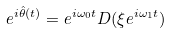Convert formula to latex. <formula><loc_0><loc_0><loc_500><loc_500>e ^ { i \hat { \theta } ( t ) } = e ^ { i \omega _ { 0 } t } D ( \xi e ^ { i \omega _ { 1 } t } )</formula> 